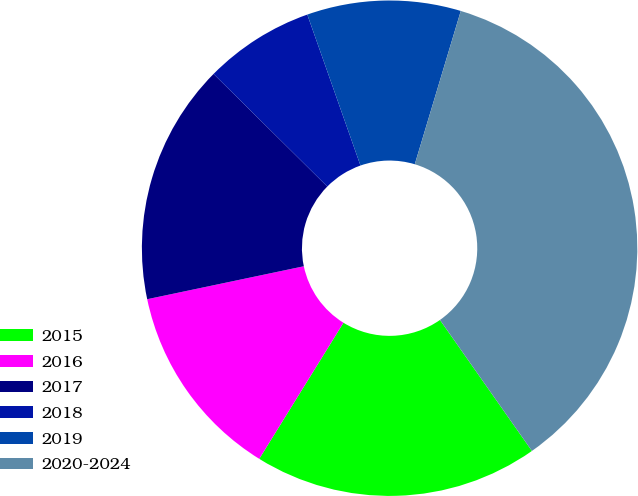Convert chart to OTSL. <chart><loc_0><loc_0><loc_500><loc_500><pie_chart><fcel>2015<fcel>2016<fcel>2017<fcel>2018<fcel>2019<fcel>2020-2024<nl><fcel>18.56%<fcel>12.88%<fcel>15.72%<fcel>7.19%<fcel>10.03%<fcel>35.62%<nl></chart> 